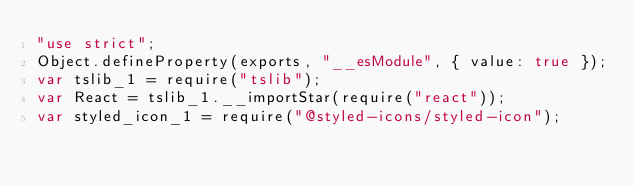Convert code to text. <code><loc_0><loc_0><loc_500><loc_500><_JavaScript_>"use strict";
Object.defineProperty(exports, "__esModule", { value: true });
var tslib_1 = require("tslib");
var React = tslib_1.__importStar(require("react"));
var styled_icon_1 = require("@styled-icons/styled-icon");</code> 